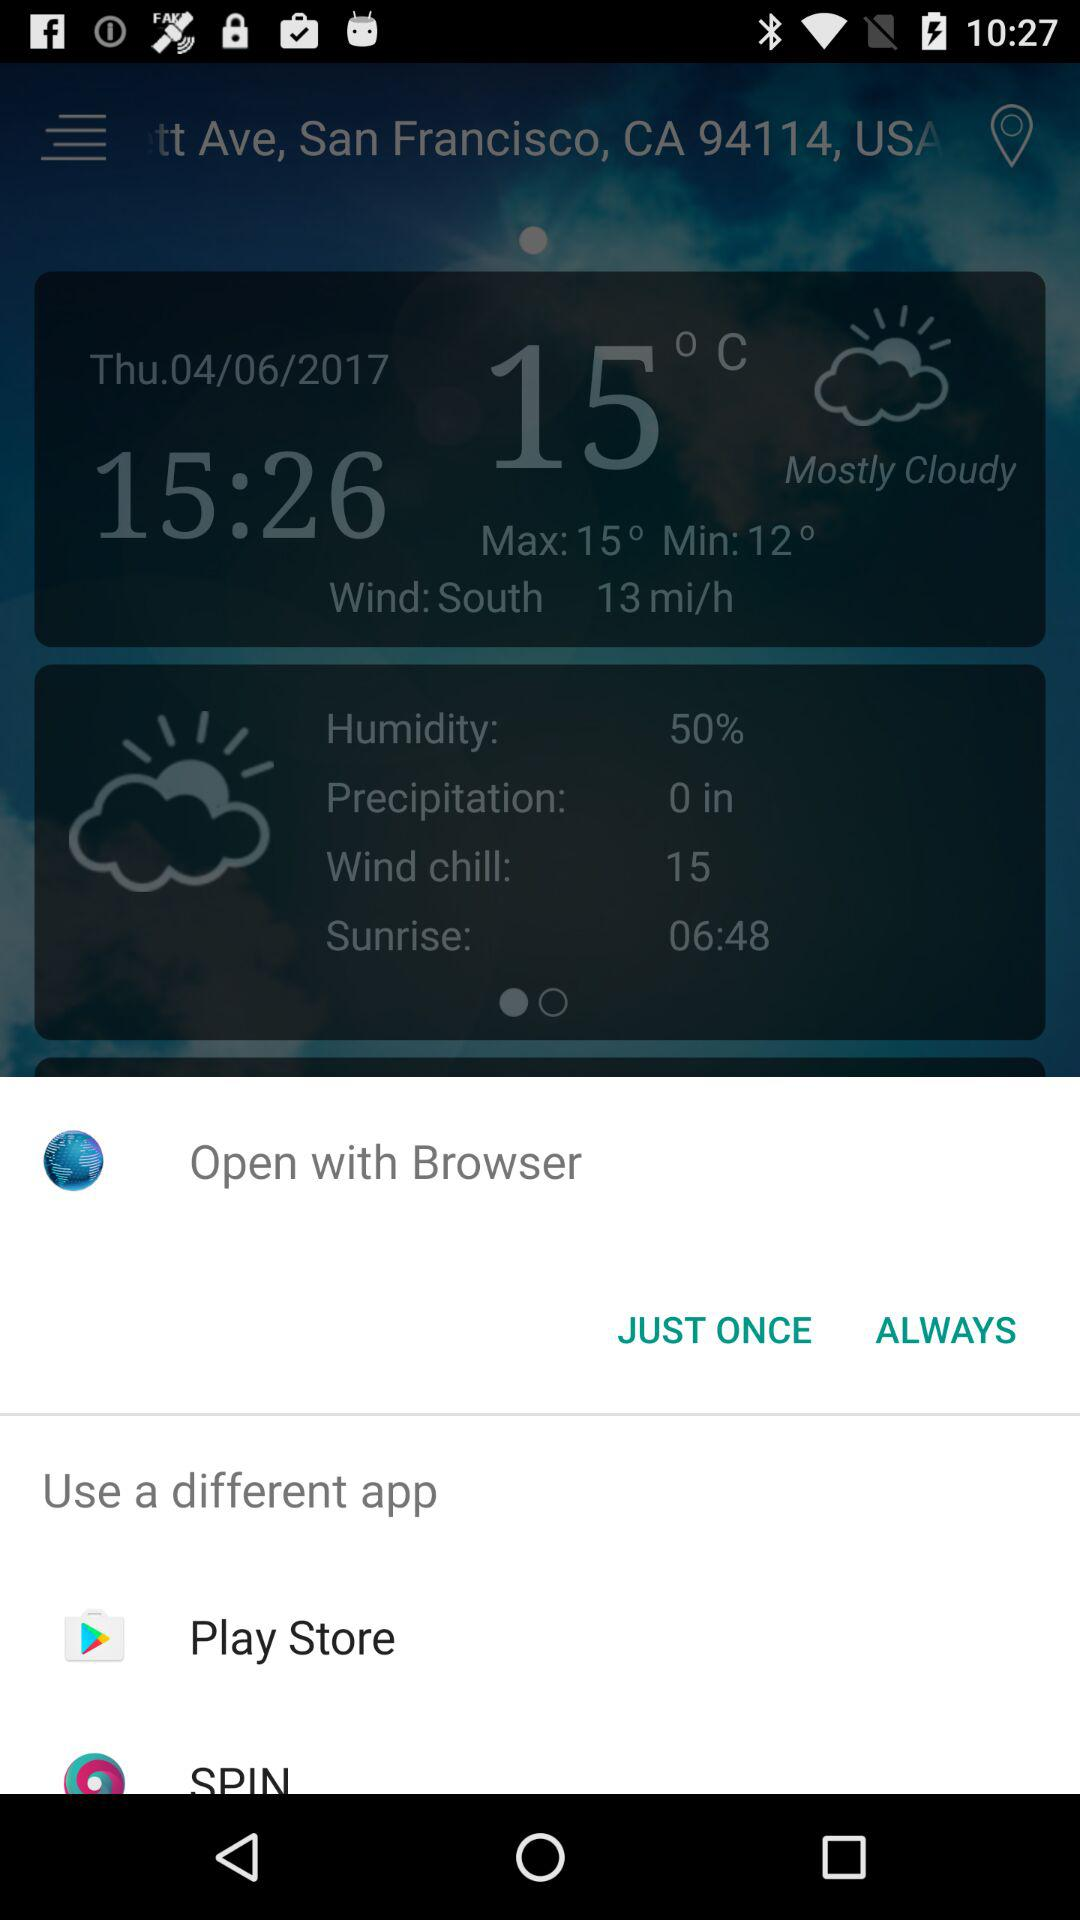What is the weather like? The weather is mostly cloudy. 